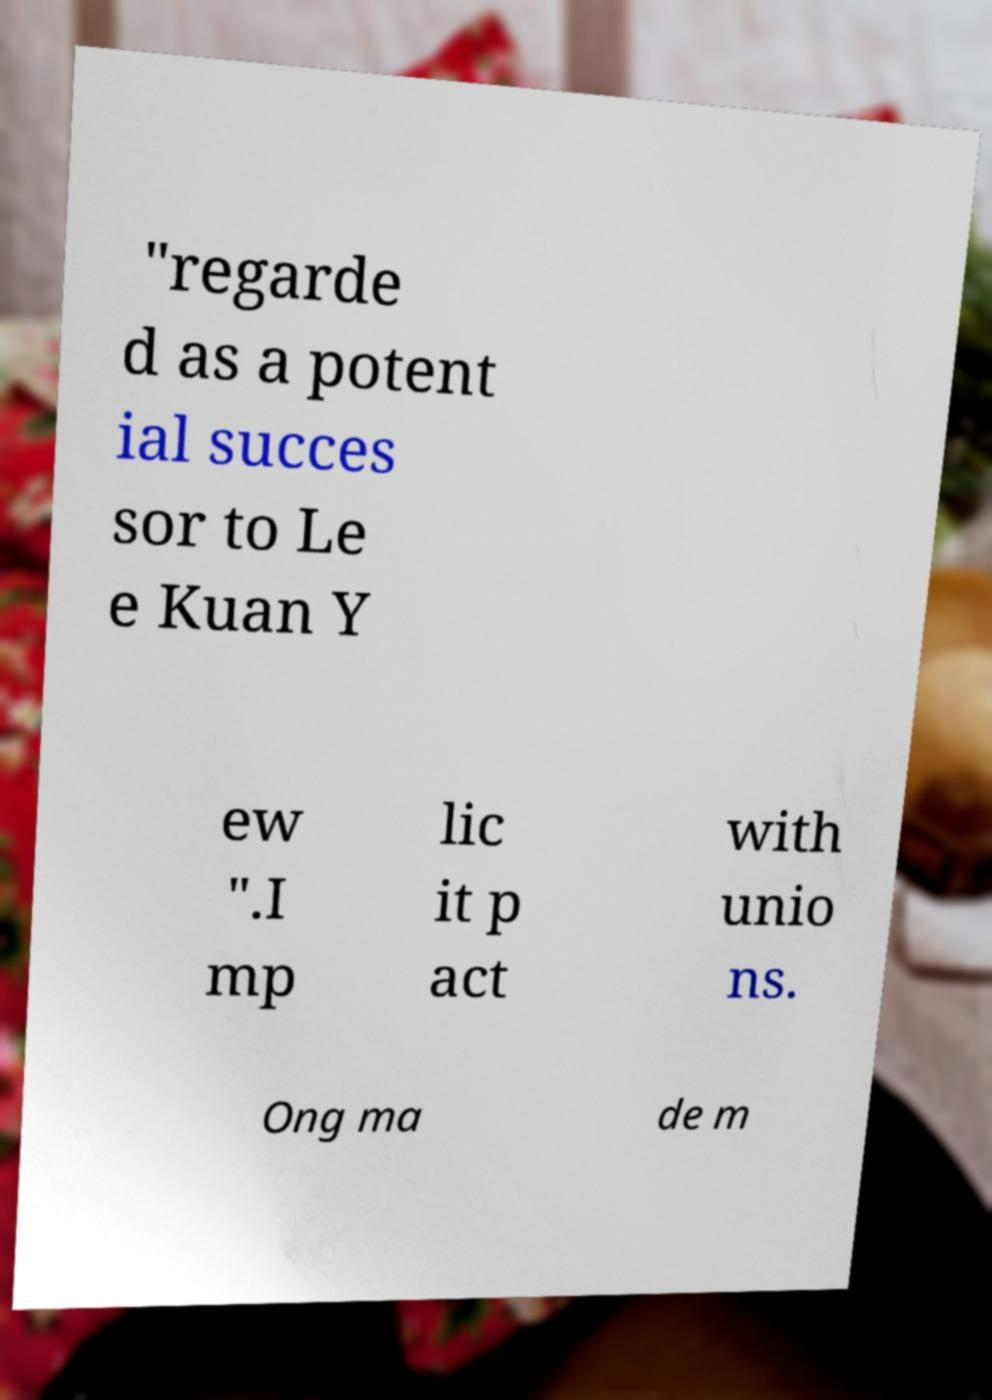There's text embedded in this image that I need extracted. Can you transcribe it verbatim? "regarde d as a potent ial succes sor to Le e Kuan Y ew ".I mp lic it p act with unio ns. Ong ma de m 